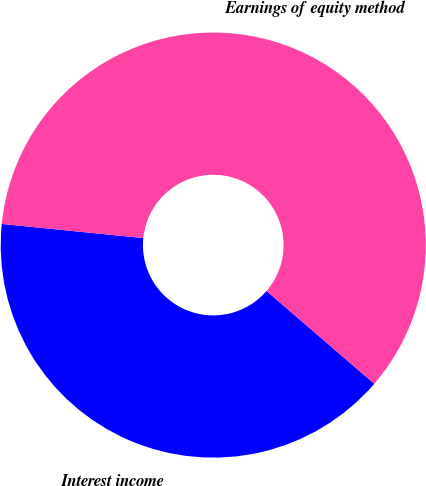Convert chart. <chart><loc_0><loc_0><loc_500><loc_500><pie_chart><fcel>Interest income<fcel>Earnings of equity method<nl><fcel>40.27%<fcel>59.73%<nl></chart> 